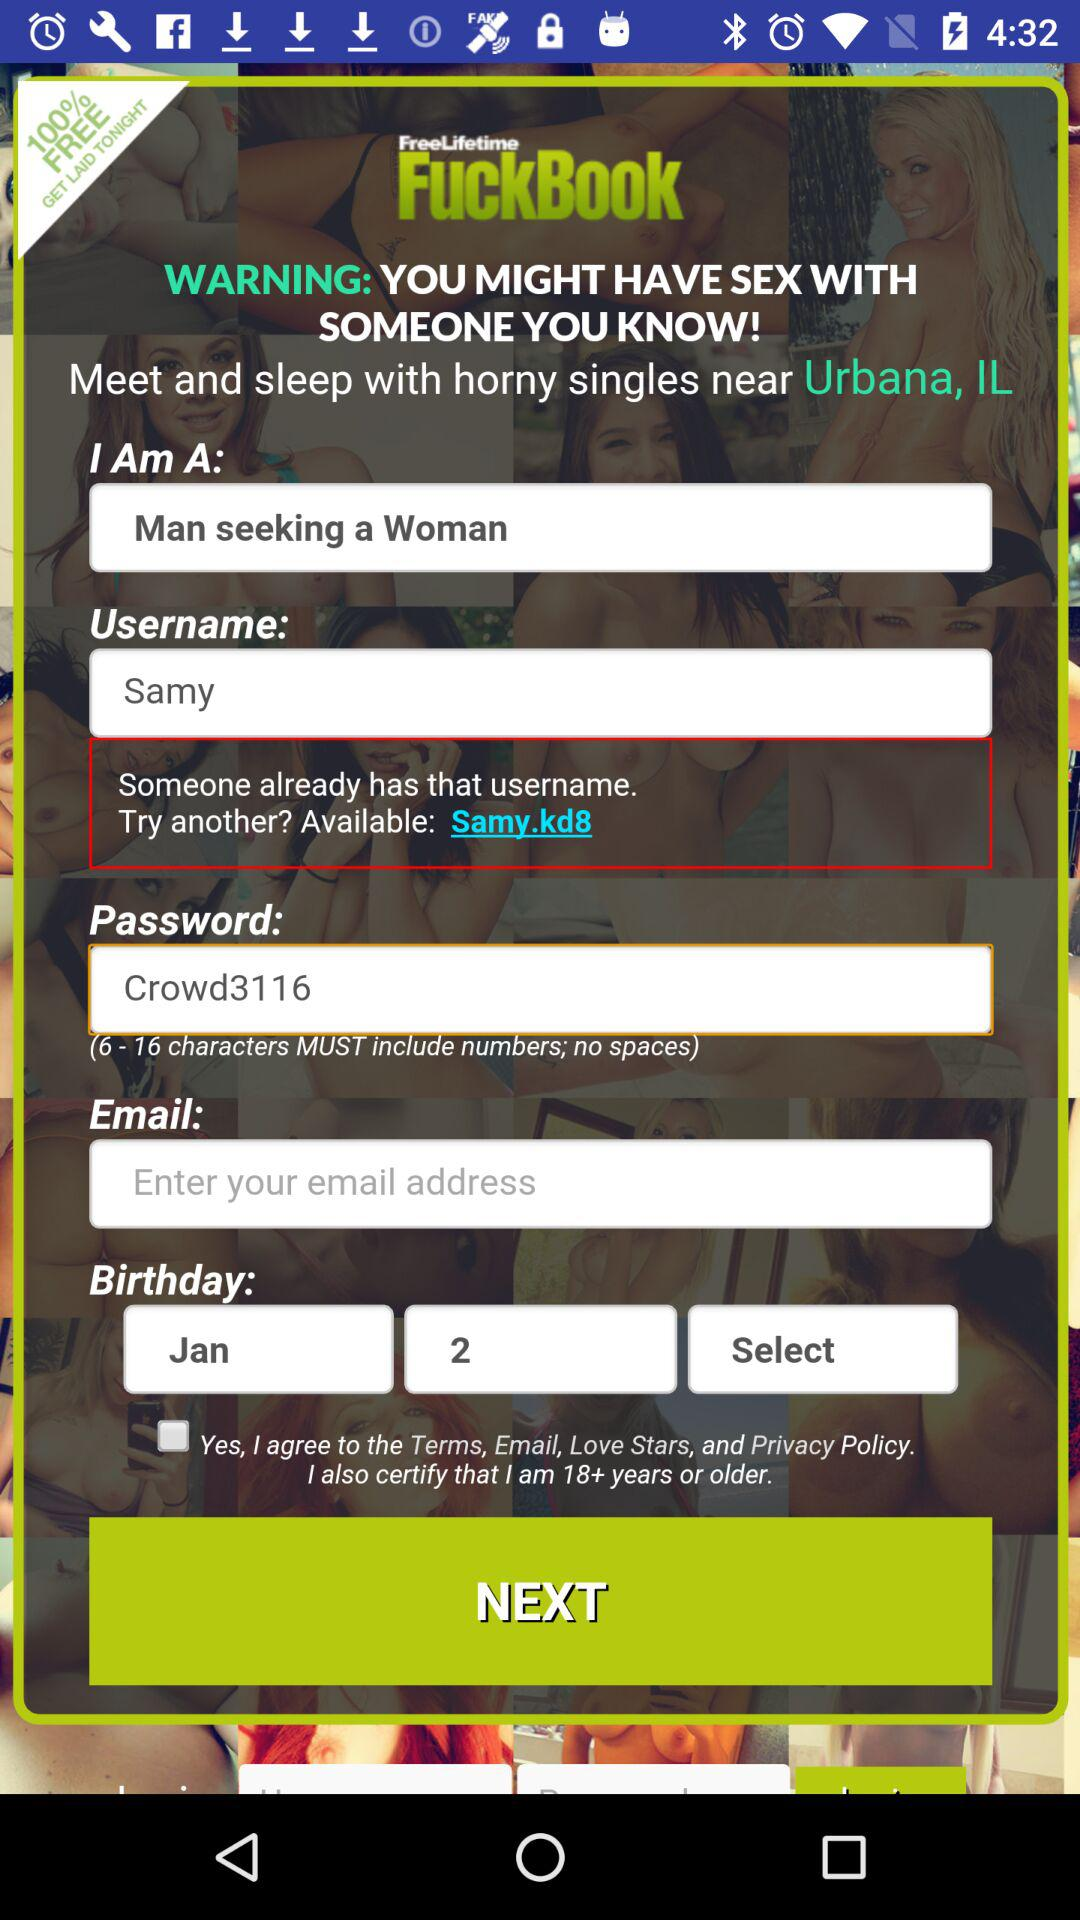How many text inputs have a warning next to them?
Answer the question using a single word or phrase. 1 